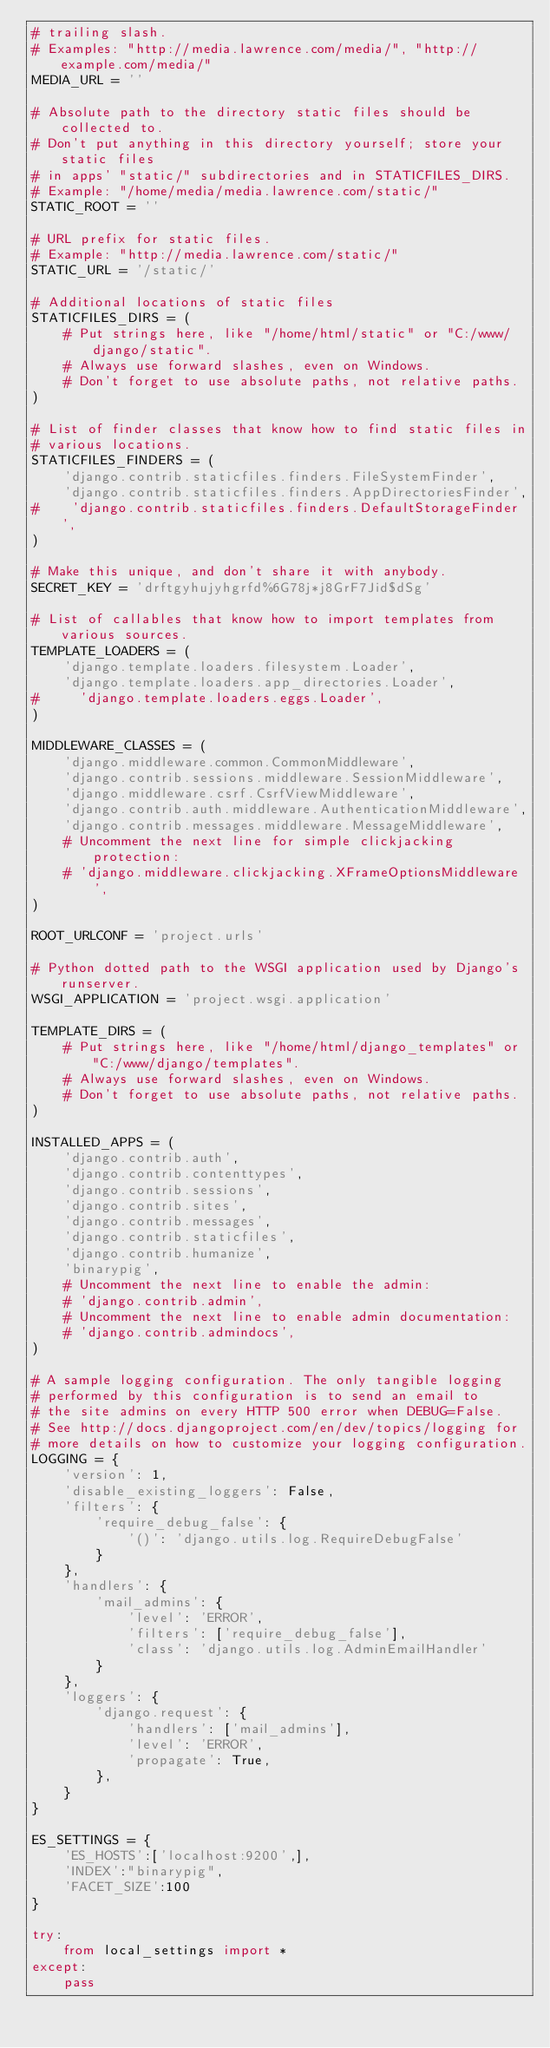<code> <loc_0><loc_0><loc_500><loc_500><_Python_># trailing slash.
# Examples: "http://media.lawrence.com/media/", "http://example.com/media/"
MEDIA_URL = ''

# Absolute path to the directory static files should be collected to.
# Don't put anything in this directory yourself; store your static files
# in apps' "static/" subdirectories and in STATICFILES_DIRS.
# Example: "/home/media/media.lawrence.com/static/"
STATIC_ROOT = ''

# URL prefix for static files.
# Example: "http://media.lawrence.com/static/"
STATIC_URL = '/static/'

# Additional locations of static files
STATICFILES_DIRS = (
    # Put strings here, like "/home/html/static" or "C:/www/django/static".
    # Always use forward slashes, even on Windows.
    # Don't forget to use absolute paths, not relative paths.
)

# List of finder classes that know how to find static files in
# various locations.
STATICFILES_FINDERS = (
    'django.contrib.staticfiles.finders.FileSystemFinder',
    'django.contrib.staticfiles.finders.AppDirectoriesFinder',
#    'django.contrib.staticfiles.finders.DefaultStorageFinder',
)

# Make this unique, and don't share it with anybody.
SECRET_KEY = 'drftgyhujyhgrfd%6G78j*j8GrF7Jid$dSg'

# List of callables that know how to import templates from various sources.
TEMPLATE_LOADERS = (
    'django.template.loaders.filesystem.Loader',
    'django.template.loaders.app_directories.Loader',
#     'django.template.loaders.eggs.Loader',
)

MIDDLEWARE_CLASSES = (
    'django.middleware.common.CommonMiddleware',
    'django.contrib.sessions.middleware.SessionMiddleware',
    'django.middleware.csrf.CsrfViewMiddleware',
    'django.contrib.auth.middleware.AuthenticationMiddleware',
    'django.contrib.messages.middleware.MessageMiddleware',
    # Uncomment the next line for simple clickjacking protection:
    # 'django.middleware.clickjacking.XFrameOptionsMiddleware',
)

ROOT_URLCONF = 'project.urls'

# Python dotted path to the WSGI application used by Django's runserver.
WSGI_APPLICATION = 'project.wsgi.application'

TEMPLATE_DIRS = (
    # Put strings here, like "/home/html/django_templates" or "C:/www/django/templates".
    # Always use forward slashes, even on Windows.
    # Don't forget to use absolute paths, not relative paths.
)

INSTALLED_APPS = (
    'django.contrib.auth',
    'django.contrib.contenttypes',
    'django.contrib.sessions',
    'django.contrib.sites',
    'django.contrib.messages',
    'django.contrib.staticfiles',
    'django.contrib.humanize',
    'binarypig',
    # Uncomment the next line to enable the admin:
    # 'django.contrib.admin',
    # Uncomment the next line to enable admin documentation:
    # 'django.contrib.admindocs',
)

# A sample logging configuration. The only tangible logging
# performed by this configuration is to send an email to
# the site admins on every HTTP 500 error when DEBUG=False.
# See http://docs.djangoproject.com/en/dev/topics/logging for
# more details on how to customize your logging configuration.
LOGGING = {
    'version': 1,
    'disable_existing_loggers': False,
    'filters': {
        'require_debug_false': {
            '()': 'django.utils.log.RequireDebugFalse'
        }
    },
    'handlers': {
        'mail_admins': {
            'level': 'ERROR',
            'filters': ['require_debug_false'],
            'class': 'django.utils.log.AdminEmailHandler'
        }
    },
    'loggers': {
        'django.request': {
            'handlers': ['mail_admins'],
            'level': 'ERROR',
            'propagate': True,
        },
    }
}

ES_SETTINGS = {
    'ES_HOSTS':['localhost:9200',],
    'INDEX':"binarypig",
    'FACET_SIZE':100
}

try:
    from local_settings import *
except:
    pass

</code> 